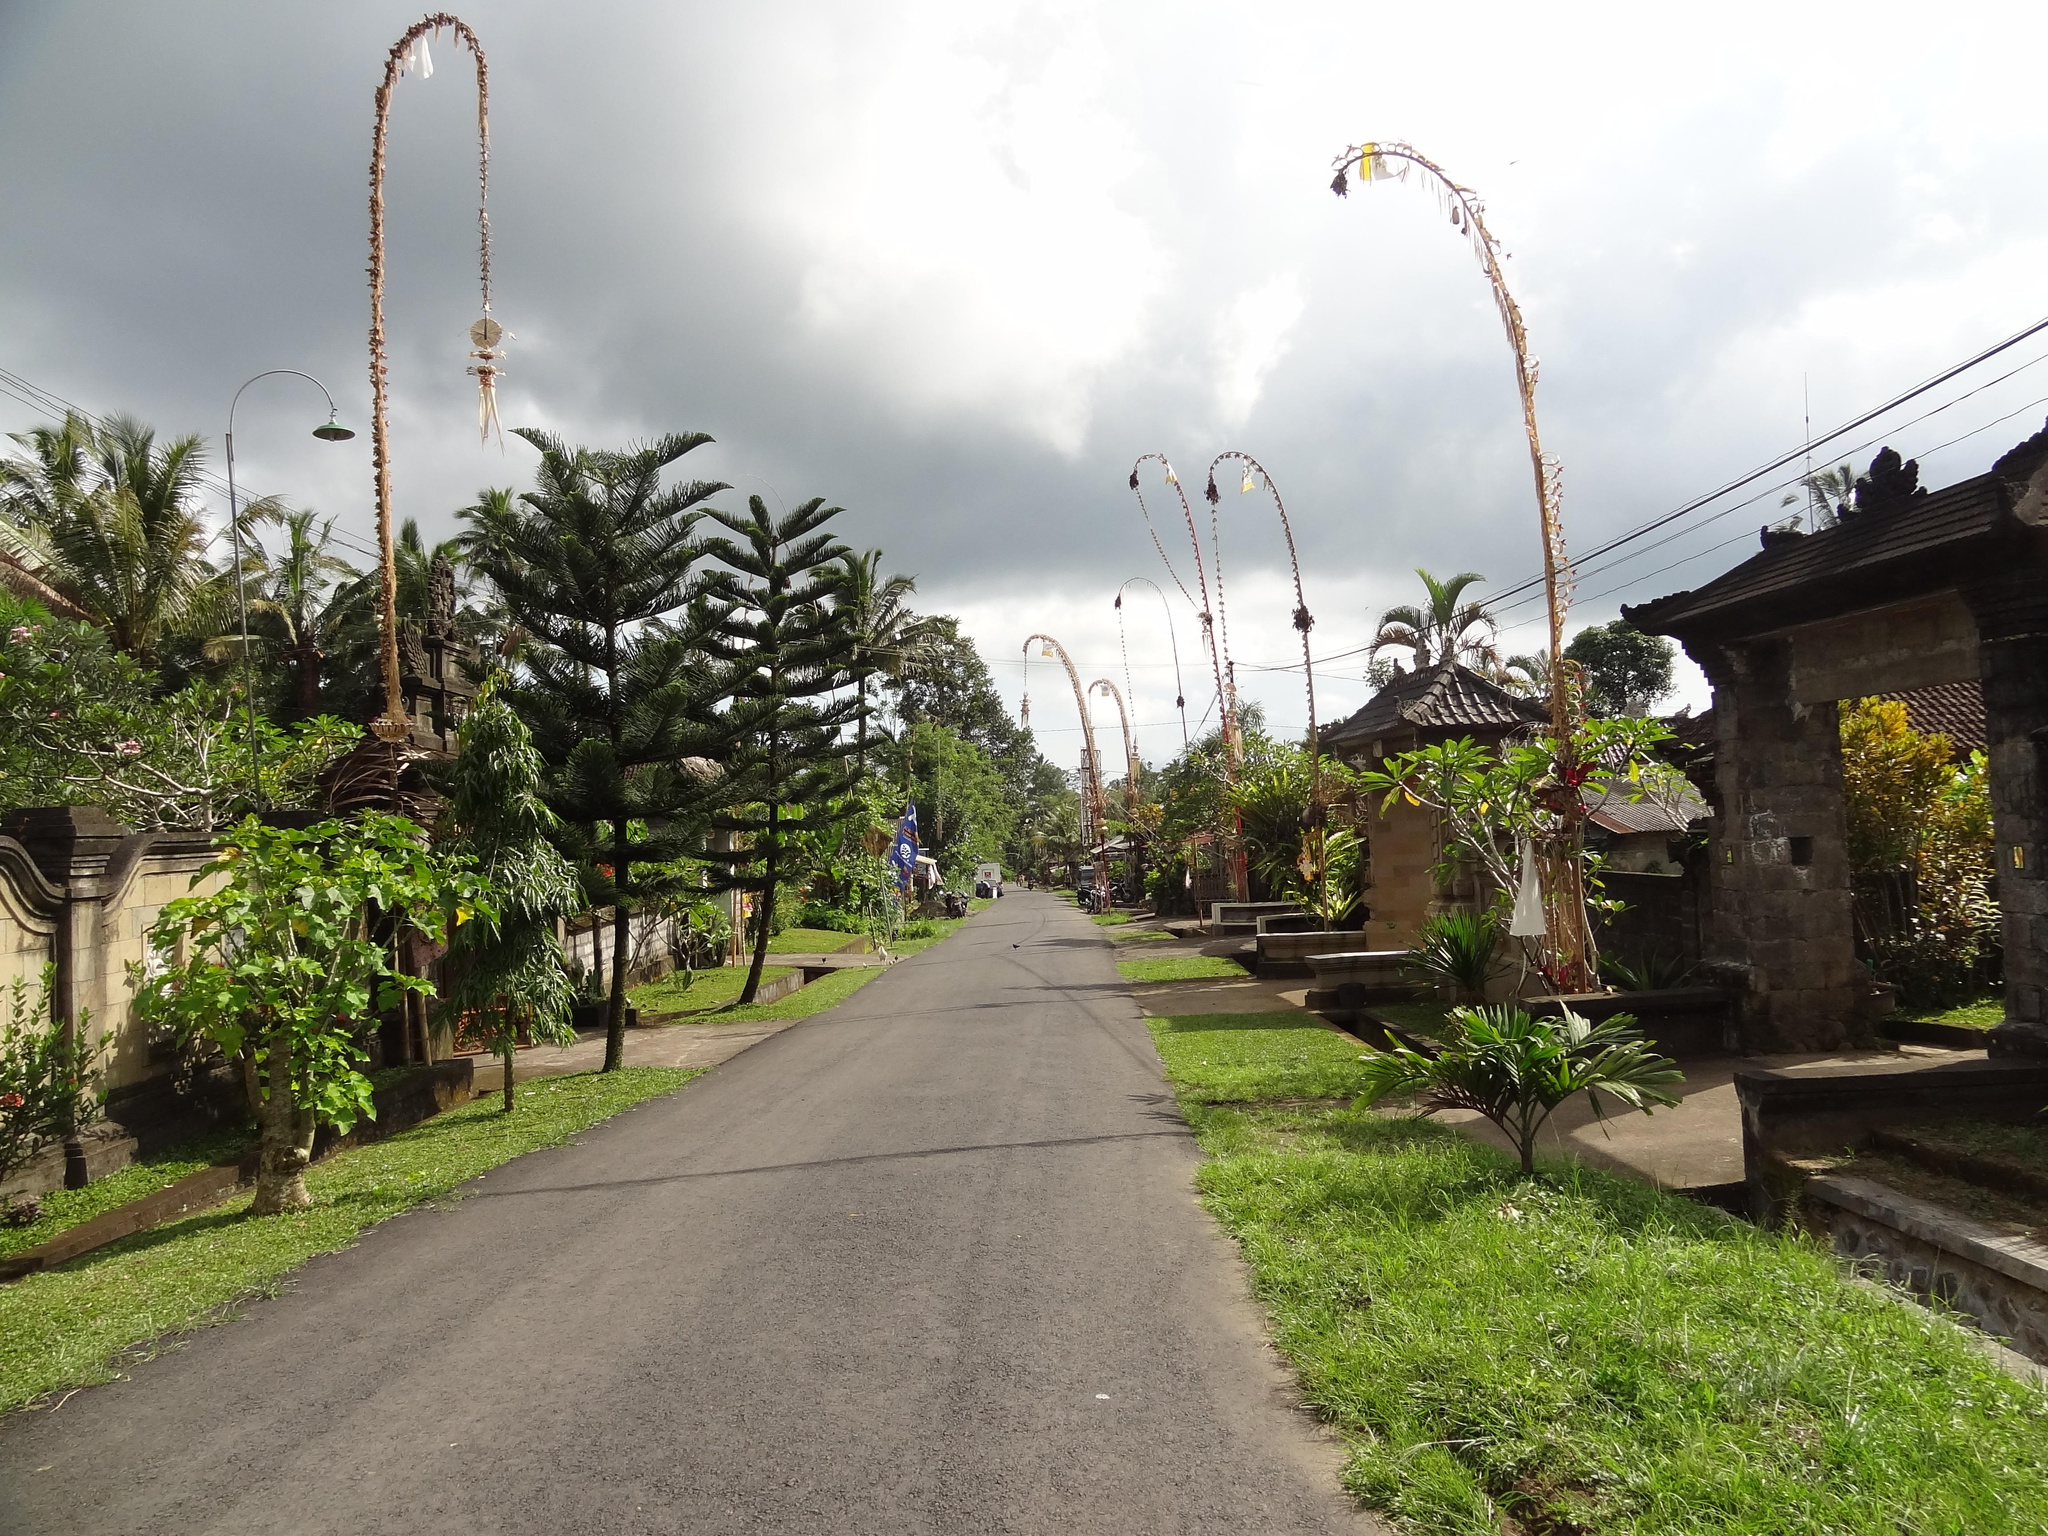What can be seen in the sky in the image? The sky is visible in the image, but no specific details about the sky are provided. What type of vegetation is present in the image? There are trees, grass, and plants in the image. What is the nature of the surface in the image? There is a wall and a road in the image, which suggests that the surface is a mix of a vertical and horizontal surface. What else is present in the image besides the sky, trees, grass, plants, wall, and road? There are unspecified objects in the image. How many yaks can be seen walking along the road in the image? There are no yaks present in the image, and therefore no such activity can be observed. What type of company is represented by the objects in the image? The image does not depict any specific company or organization, so it is not possible to determine the type of company represented by the objects. 